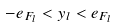<formula> <loc_0><loc_0><loc_500><loc_500>- e _ { F _ { l } } < y _ { l } < e _ { F _ { l } }</formula> 